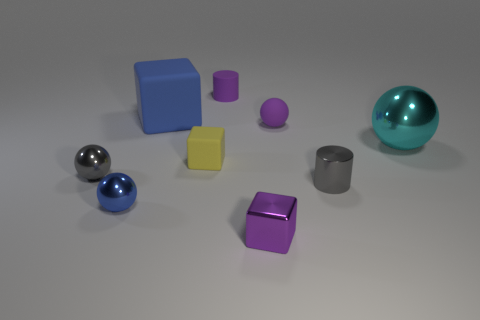Subtract all balls. How many objects are left? 5 Subtract 1 cyan balls. How many objects are left? 8 Subtract all large blue matte cubes. Subtract all cylinders. How many objects are left? 6 Add 4 big blocks. How many big blocks are left? 5 Add 6 small blue rubber blocks. How many small blue rubber blocks exist? 6 